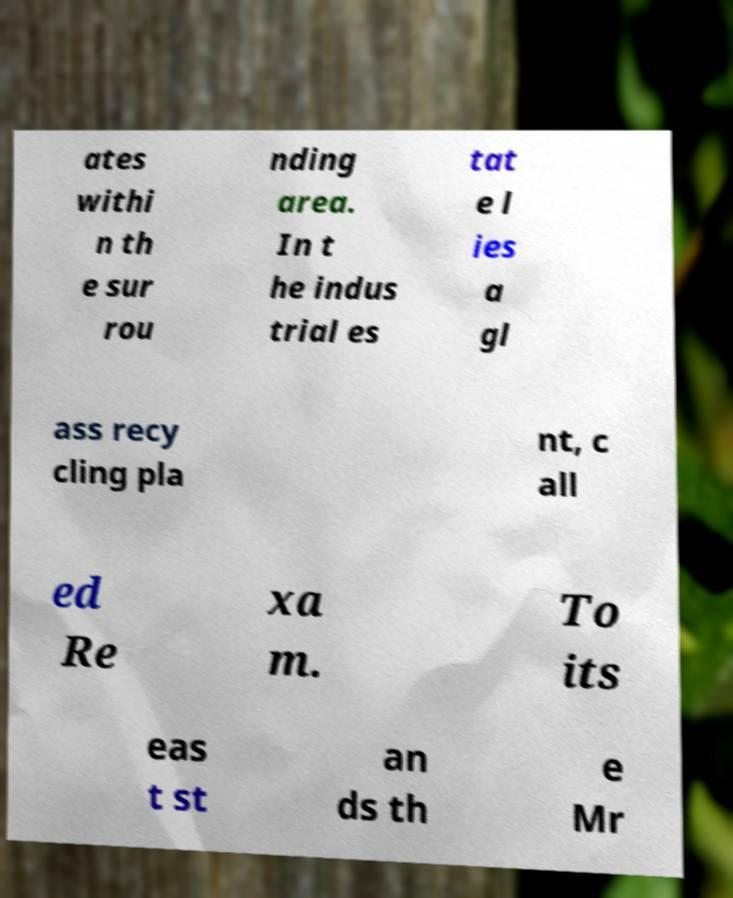Please identify and transcribe the text found in this image. ates withi n th e sur rou nding area. In t he indus trial es tat e l ies a gl ass recy cling pla nt, c all ed Re xa m. To its eas t st an ds th e Mr 